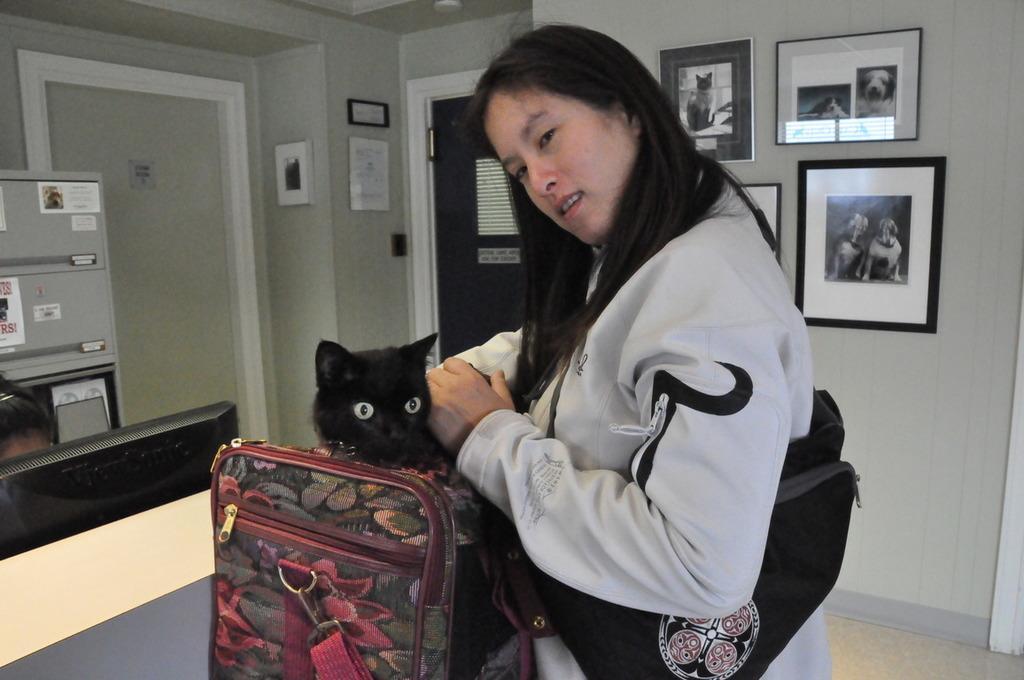Could you give a brief overview of what you see in this image? This is a picture taken in a room, the woman is holding a black cat in a bag. Background of this woman is a wall with photos and a door. 